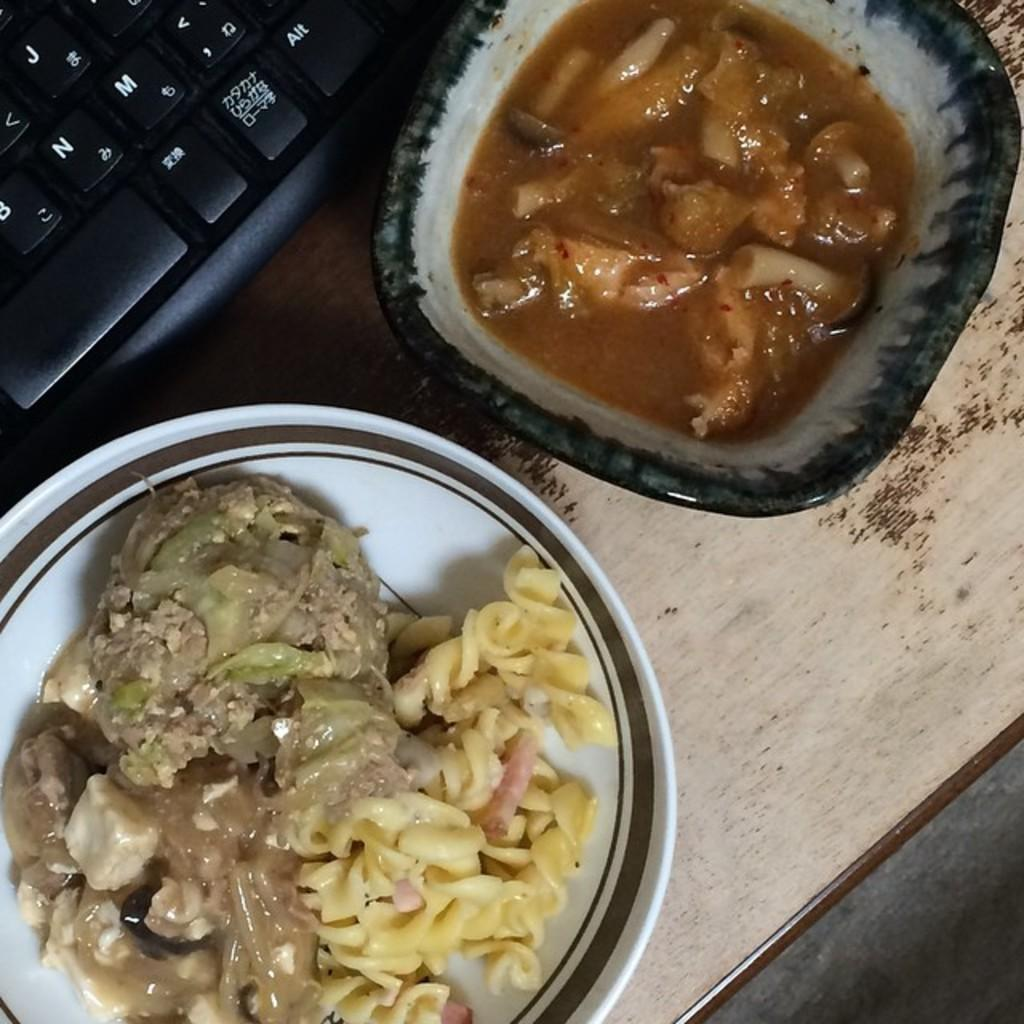What is the main object in the image? There is a keyboard in the image. What else can be seen on the wooden surface? There are food items in bowls in the image. Can you describe the surface on which the objects are placed? The objects are on a wooden surface. How many cattle can be seen in the image? There are no cattle present in the image. 